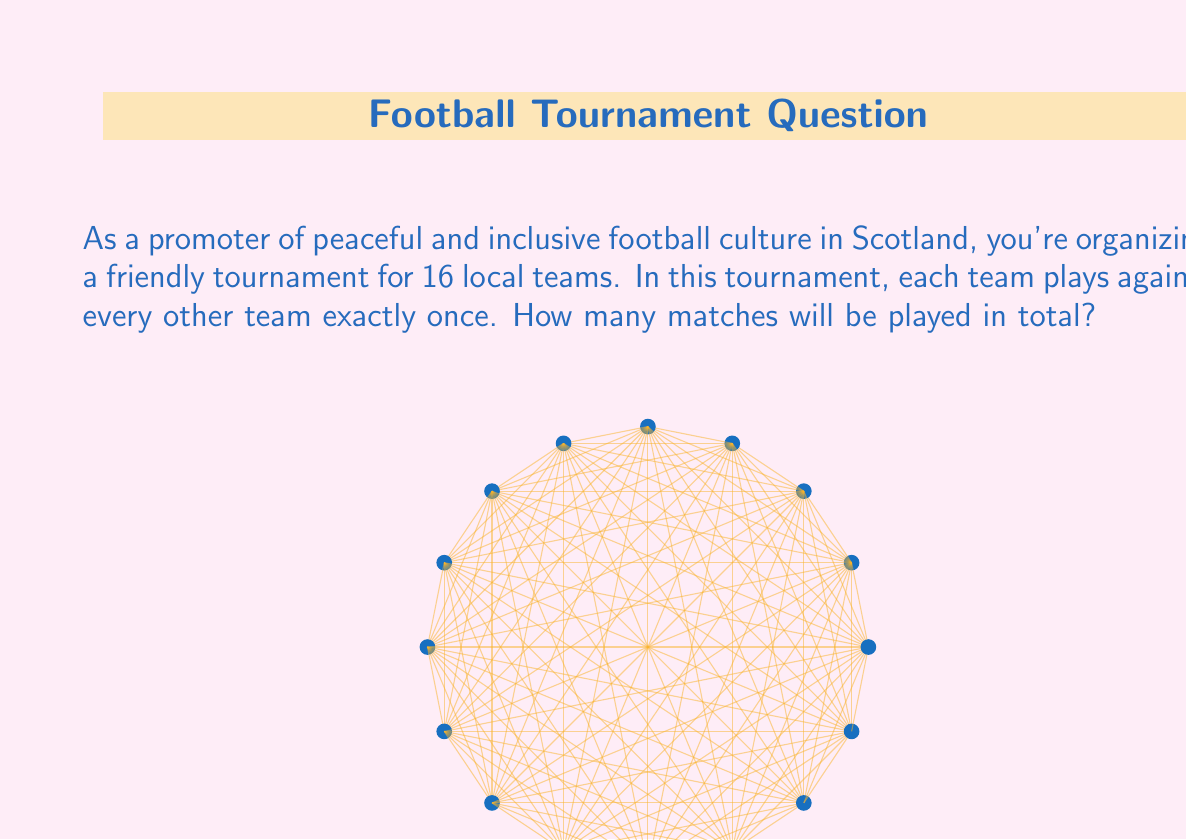Help me with this question. Let's approach this step-by-step:

1) In this tournament, each team needs to play against every other team once. This is known as a round-robin tournament.

2) To calculate the total number of matches, we need to determine how many unique pairings of teams are possible.

3) We can use the combination formula for this. We're choosing 2 teams out of 16 for each match.

4) The formula for combinations is:

   $$C(n,r) = \frac{n!}{r!(n-r)!}$$

   where $n$ is the total number of items (in this case, teams) and $r$ is the number of items being chosen at a time (in this case, 2 for each match).

5) Substituting our values:

   $$C(16,2) = \frac{16!}{2!(16-2)!} = \frac{16!}{2!(14)!}$$

6) Simplifying:

   $$\frac{16 \cdot 15 \cdot 14!}{2 \cdot 1 \cdot 14!} = \frac{16 \cdot 15}{2 \cdot 1} = \frac{240}{2} = 120$$

Therefore, there will be 120 matches in total in this tournament.
Answer: 120 matches 